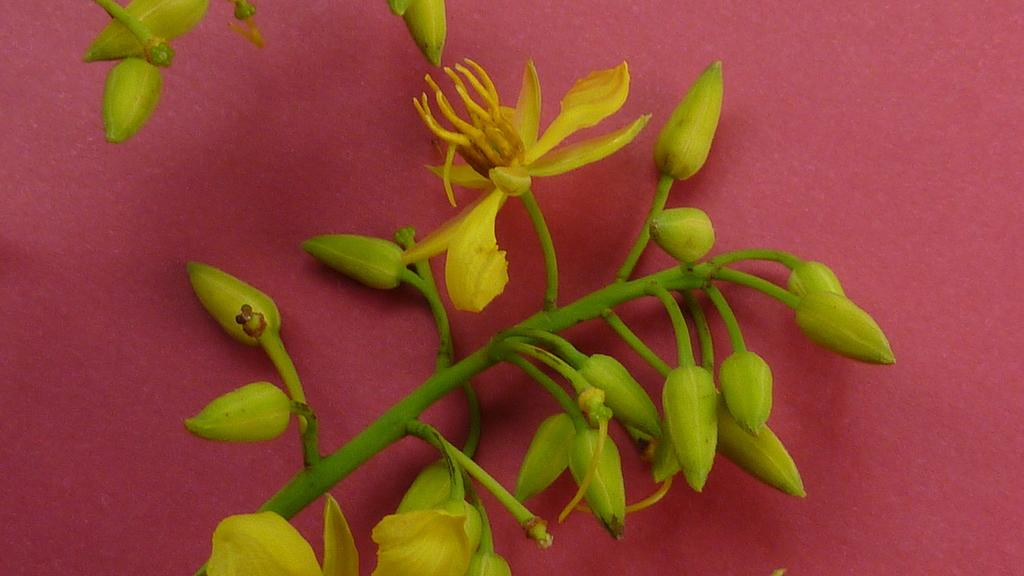What type of plant is visible in the image? There is a plant in the image, and it has flowers and buds. What color is the surface on which the plant is placed? The plant is on a red surface. Where are the buds located on the plant? There are buds on the stem at the top of the image. What type of fire can be seen burning in the image? There is no fire present in the image; it features a plant with flowers and buds on a red surface. What cast member from the movie "The Lion King" can be seen in the image? There are no cast members or characters from any movie present in the image; it features a plant with flowers and buds on a red surface. 